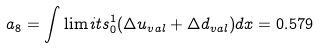Convert formula to latex. <formula><loc_0><loc_0><loc_500><loc_500>a _ { 8 } = \int \lim i t s _ { 0 } ^ { 1 } ( \Delta u _ { v a l } + \Delta d _ { v a l } ) d x = 0 . 5 7 9</formula> 